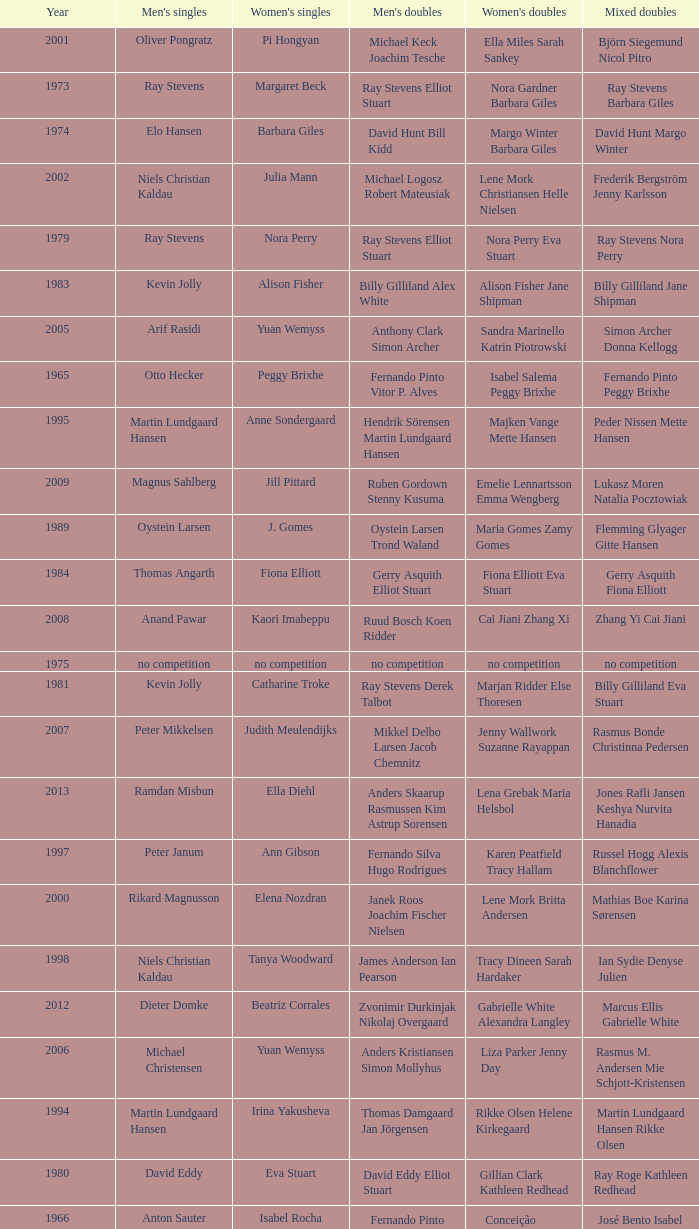Can you give me this table as a dict? {'header': ['Year', "Men's singles", "Women's singles", "Men's doubles", "Women's doubles", 'Mixed doubles'], 'rows': [['2001', 'Oliver Pongratz', 'Pi Hongyan', 'Michael Keck Joachim Tesche', 'Ella Miles Sarah Sankey', 'Björn Siegemund Nicol Pitro'], ['1973', 'Ray Stevens', 'Margaret Beck', 'Ray Stevens Elliot Stuart', 'Nora Gardner Barbara Giles', 'Ray Stevens Barbara Giles'], ['1974', 'Elo Hansen', 'Barbara Giles', 'David Hunt Bill Kidd', 'Margo Winter Barbara Giles', 'David Hunt Margo Winter'], ['2002', 'Niels Christian Kaldau', 'Julia Mann', 'Michael Logosz Robert Mateusiak', 'Lene Mork Christiansen Helle Nielsen', 'Frederik Bergström Jenny Karlsson'], ['1979', 'Ray Stevens', 'Nora Perry', 'Ray Stevens Elliot Stuart', 'Nora Perry Eva Stuart', 'Ray Stevens Nora Perry'], ['1983', 'Kevin Jolly', 'Alison Fisher', 'Billy Gilliland Alex White', 'Alison Fisher Jane Shipman', 'Billy Gilliland Jane Shipman'], ['2005', 'Arif Rasidi', 'Yuan Wemyss', 'Anthony Clark Simon Archer', 'Sandra Marinello Katrin Piotrowski', 'Simon Archer Donna Kellogg'], ['1965', 'Otto Hecker', 'Peggy Brixhe', 'Fernando Pinto Vitor P. Alves', 'Isabel Salema Peggy Brixhe', 'Fernando Pinto Peggy Brixhe'], ['1995', 'Martin Lundgaard Hansen', 'Anne Sondergaard', 'Hendrik Sörensen Martin Lundgaard Hansen', 'Majken Vange Mette Hansen', 'Peder Nissen Mette Hansen'], ['2009', 'Magnus Sahlberg', 'Jill Pittard', 'Ruben Gordown Stenny Kusuma', 'Emelie Lennartsson Emma Wengberg', 'Lukasz Moren Natalia Pocztowiak'], ['1989', 'Oystein Larsen', 'J. Gomes', 'Oystein Larsen Trond Waland', 'Maria Gomes Zamy Gomes', 'Flemming Glyager Gitte Hansen'], ['1984', 'Thomas Angarth', 'Fiona Elliott', 'Gerry Asquith Elliot Stuart', 'Fiona Elliott Eva Stuart', 'Gerry Asquith Fiona Elliott'], ['2008', 'Anand Pawar', 'Kaori Imabeppu', 'Ruud Bosch Koen Ridder', 'Cai Jiani Zhang Xi', 'Zhang Yi Cai Jiani'], ['1975', 'no competition', 'no competition', 'no competition', 'no competition', 'no competition'], ['1981', 'Kevin Jolly', 'Catharine Troke', 'Ray Stevens Derek Talbot', 'Marjan Ridder Else Thoresen', 'Billy Gilliland Eva Stuart'], ['2007', 'Peter Mikkelsen', 'Judith Meulendijks', 'Mikkel Delbo Larsen Jacob Chemnitz', 'Jenny Wallwork Suzanne Rayappan', 'Rasmus Bonde Christinna Pedersen'], ['2013', 'Ramdan Misbun', 'Ella Diehl', 'Anders Skaarup Rasmussen Kim Astrup Sorensen', 'Lena Grebak Maria Helsbol', 'Jones Rafli Jansen Keshya Nurvita Hanadia'], ['1997', 'Peter Janum', 'Ann Gibson', 'Fernando Silva Hugo Rodrigues', 'Karen Peatfield Tracy Hallam', 'Russel Hogg Alexis Blanchflower'], ['2000', 'Rikard Magnusson', 'Elena Nozdran', 'Janek Roos Joachim Fischer Nielsen', 'Lene Mork Britta Andersen', 'Mathias Boe Karina Sørensen'], ['1998', 'Niels Christian Kaldau', 'Tanya Woodward', 'James Anderson Ian Pearson', 'Tracy Dineen Sarah Hardaker', 'Ian Sydie Denyse Julien'], ['2012', 'Dieter Domke', 'Beatriz Corrales', 'Zvonimir Durkinjak Nikolaj Overgaard', 'Gabrielle White Alexandra Langley', 'Marcus Ellis Gabrielle White'], ['2006', 'Michael Christensen', 'Yuan Wemyss', 'Anders Kristiansen Simon Mollyhus', 'Liza Parker Jenny Day', 'Rasmus M. Andersen Mie Schjott-Kristensen'], ['1994', 'Martin Lundgaard Hansen', 'Irina Yakusheva', 'Thomas Damgaard Jan Jörgensen', 'Rikke Olsen Helene Kirkegaard', 'Martin Lundgaard Hansen Rikke Olsen'], ['1980', 'David Eddy', 'Eva Stuart', 'David Eddy Elliot Stuart', 'Gillian Clark Kathleen Redhead', 'Ray Roge Kathleen Redhead'], ['1966', 'Anton Sauter', 'Isabel Rocha', 'Fernando Pinto Vitor P. Alves', 'Conceição Felizardo Isabel Rocha', 'José Bento Isabel Rocha'], ['1991', 'Anders Nielsen', 'Astrid van der Knaap', 'Andy Goode Glen Milton', 'Elena Denisova Marina Yakusheva', 'Chris Hunt Tracy Dineen'], ['1992', 'Andrey Antropov', 'Elena Rybkina', 'Andy Goode Chris Hunt', 'Joanne Wright Joanne Davies', 'Andy Goode Joanne Wright'], ['1993', 'Andrey Antropov', 'Marina Andrievskaia', 'Chan Kin Ngai Wong Wai Lap', 'Marina Andrievskaja Irina Yakusheva', 'Nikolaj Zuev Marina Yakusheva'], ['1969', 'Jan Holtnaes', 'Isabel Rocha', 'Jan Holtnaes Anton Sauter', 'no competition', 'Jan Holtnaes Susan Bennett'], ['2011', 'Sven-Eric Kastens', 'Sashina Vignes Waran', 'Niclas Nohr Mads Pedersen', 'Lauren Smith Alexandra Langley', 'Robin Middleton Alexandra Langley'], ['1986', 'Ken Middlemiss', 'Eva Stuart', 'David Eddy Elliot Stuart', 'Margarida Cruz Paula Sousa', 'Ken Middlemiss Margarida Cruz'], ['1996', 'Rikard Magnusson', 'Karolina Ericsson', 'Ian Pearson James Anderson', 'Emma Chaffin Tracy Hallam', 'Nathan Robertson Gail Emms'], ['1976', 'Michael Wilks', 'Jane Webster', 'Michael Wilks Peter Bullivant', 'Jane Webster Kathleen Redhead', 'Peter Bullivant Kathleen Redhead'], ['1990', 'Peter Smith', 'Julia Mann', 'Peter Smith Nittin Panesar', 'Julia Mann Tania Growes', 'Nittin Panesar Tania Growes'], ['2010', 'Kenn Lim', 'Telma Santos', 'Martin Kragh Anders Skaarup Rasmussen', 'Lauren Smith Alexandra Langley', 'Zvonimir Durkinjak Stasa Poznanovic'], ['1999', 'Peter Janum', 'Ella Karachkova', 'Manuel Dubrulle Vicent Laigle', 'Sara Sankey Ella Miles', 'Björn Siegemund Karen Stechmann'], ['1988', 'Stéphane Renault', 'Christelle Mol', 'Nick Pettman Jon Pulford', 'Cecilia Brun Christelle Mol', 'José Nascimento Christelle Mol'], ['1972', 'Philip Smith', 'Nora Gardner', 'Eddy Sutton Bill Kidd', 'Nora Gardner Barbara Giles', 'Bill Kidd Barbara Giles'], ['1971', 'Anton Sauter', 'Fina Salazar', 'Anton Sauter Erich Linnemann', 'no competition', 'Alfredo Salazar Fina Salazar'], ['1985', 'Niels Skeby', 'Fiona Elliott', 'Niels Skeby Poul Erik Hoyer Larsen', 'Fiona Elliot J. Elliot', 'Mark Elliott Fiona Elliott'], ['1987', 'P. Patel', 'Pernille Dupont', 'David Eddy Elliot Stuart', 'Pernille Dupont Lotte Olsen', 'José Nascimento Lotte Olsen'], ['1967', 'José Bento', 'Isabel Rocha', 'Fernando Pinto Francisco Lomos', 'Conceição Felizardo Isabel Rocha', 'José Azevedo Isabel Rocha'], ['1978', 'Thomas Kihlström', 'Marjan Ridder', 'Thomas Kihlström Bengt Fröman', 'Barbara Sutton Paula Kilvington', 'Eddy Sutton Barbara Sutton'], ['2003', 'Niels Christian Kaldau', 'Pi Hongyan', 'Jim Laugesen Michael Søgaard', 'Julie Houmann Helle Nielsen', 'Fredrik Bergström Johanna Persson'], ['1977', 'Tariq Farooq', 'Karen Bridge', 'Ola Eriksson Christian Lundberg', 'Karen Bridge Anne Statt', 'Tim Stokes Karen Bridge'], ['1970', 'Erich Linnemann', 'Peggy Brixhe', 'Anton Sauter Erich Linnemann', 'Helena Dias Isabel Rocha', 'José Bento Isabel Rocha'], ['1982', 'Ray Stevens', 'Catharine Troke', 'Ray Stevens Darren Hall', 'Nora Perry Catharine Troke', 'Ray Stevens Nora Perry'], ['2004', 'Stanislav Pukhov', 'Tracey Hallam', 'Simon Archer Robert Blair', 'Nadieżda Kostiuczyk Kamila Augustyn', 'Simon Archer Donna Kellogg'], ['1968', 'Oscar Lujan', 'no competition', 'Oscar Lujan Monge Dias', 'no competition', 'Jan Holtnaes Cecilia Geirithas']]} What is the average year with alfredo salazar fina salazar in mixed doubles? 1971.0. 